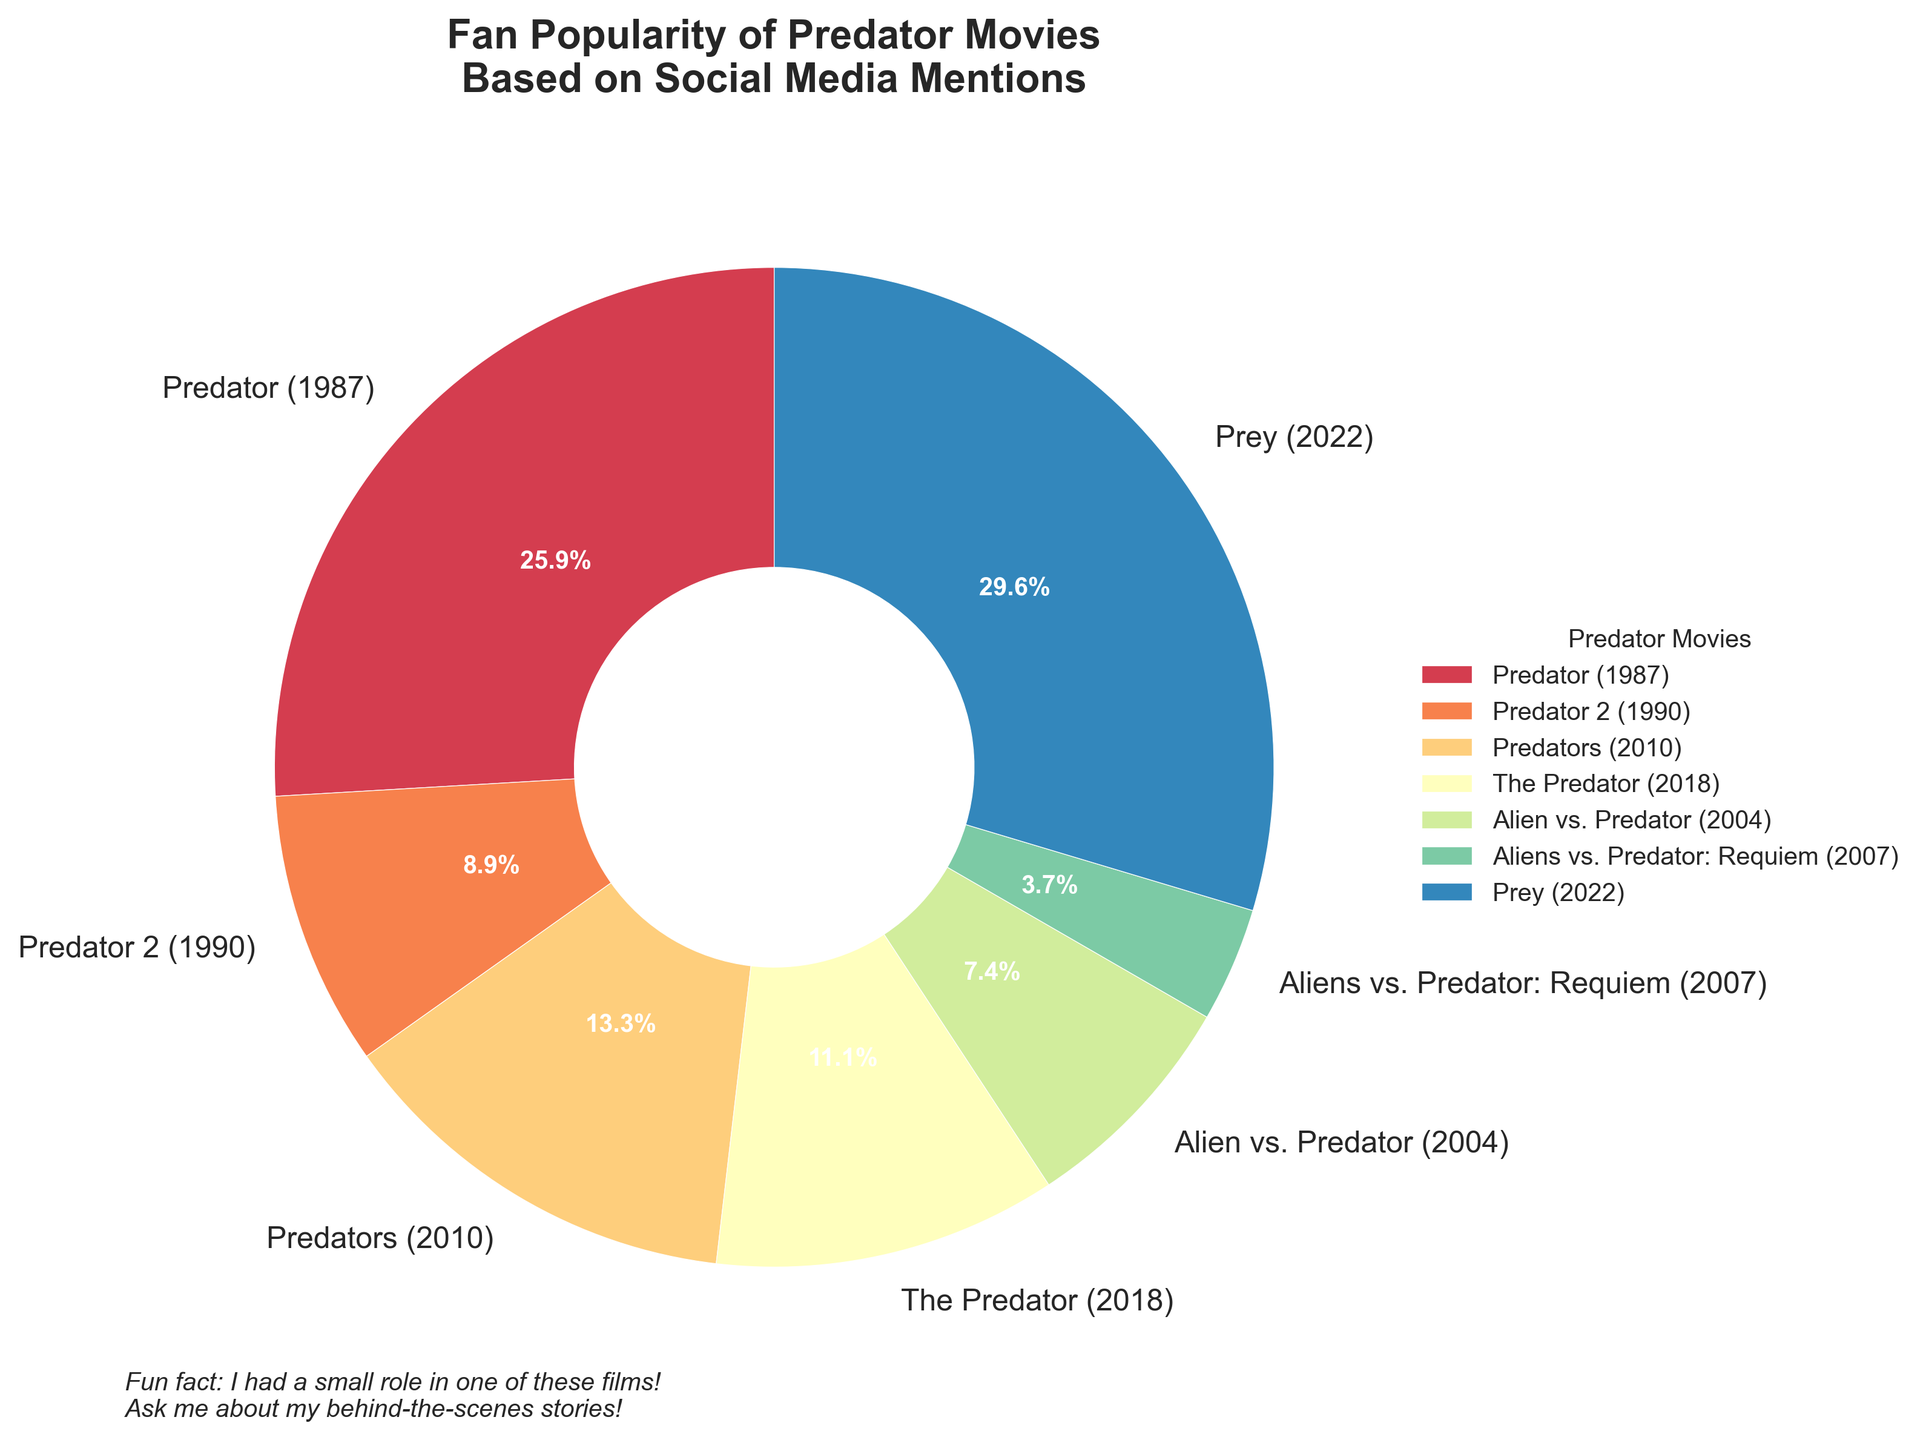What percentage of social media mentions does "Predator (1987)" have? "Predator (1987)" has been mentioned 35 times. The total number of social media mentions is 135. The percentage is calculated as (35 / 135) * 100 = 25.9%.
Answer: 25.9% Which movie installment has the fewest social media mentions? The installment with the fewest social media mentions is "Aliens vs. Predator: Requiem (2007)", which has 5 mentions.
Answer: Aliens vs. Predator: Requiem (2007) Is the number of mentions for "The Predator (2018)" and "Predators (2010)" combined greater than those for "Prey (2022)"? "The Predator (2018)" has 15 mentions and "Predators (2010)" has 18 mentions. Their combined total is 15 + 18 = 33. "Prey (2022)" has 40 mentions, which is greater than 33.
Answer: No What is the difference in mentions between the most mentioned and least mentioned movies? The most mentioned movie is "Prey (2022)" with 40 mentions, and the least mentioned is "Aliens vs. Predator: Requiem (2007)" with 5 mentions. The difference is 40 - 5 = 35 mentions.
Answer: 35 How many more mentions does "Prey (2022)" have compared to "Predator (1987)"? "Prey (2022)" has 40 mentions, and "Predator (1987)" has 35 mentions. The difference is 40 - 35 = 5 mentions.
Answer: 5 Which movie has the second-highest number of social media mentions? The movie with the second-highest number of mentions is "Predator (1987)" with 35 mentions, just behind "Prey (2022)".
Answer: Predator (1987) Which movies have fewer than 20 social media mentions? The movies with fewer than 20 mentions are "Predator 2 (1990)" with 12 mentions, "The Predator (2018)" with 15 mentions, "Alien vs. Predator (2004)" with 10 mentions, and "Aliens vs. Predator: Requiem (2007)" with 5 mentions.
Answer: Predator 2 (1990), The Predator (2018), Alien vs. Predator (2004), Aliens vs. Predator: Requiem (2007) What is the average number of social media mentions across all movie installments? The total number of mentions is 135, spread over 7 movies. The average is 135 / 7 = approximately 19.3 mentions.
Answer: 19.3 Which segment of the pie chart covers the largest area? The largest segment of the pie chart covers "Prey (2022)" as it has the most social media mentions with 40, making up the largest percentage.
Answer: Prey (2022) What is the combined percentage of social media mentions for "Alien vs. Predator (2004)" and "Aliens vs. Predator: Requiem (2007)"? "Alien vs. Predator (2004)" has 10 mentions and "Aliens vs. Predator: Requiem (2007)" has 5 mentions. Combined, they have 15 mentions. The total mentions are 135. Thus, the combined percentage is (15 / 135) * 100 = 11.1%.
Answer: 11.1% 